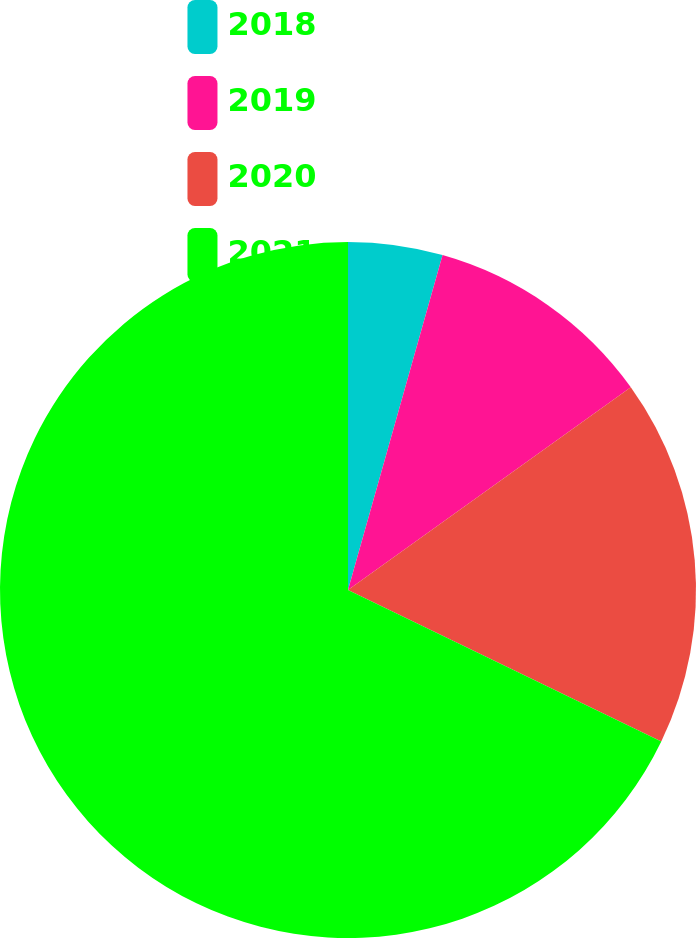<chart> <loc_0><loc_0><loc_500><loc_500><pie_chart><fcel>2018<fcel>2019<fcel>2020<fcel>2021<nl><fcel>4.38%<fcel>10.72%<fcel>17.07%<fcel>67.83%<nl></chart> 